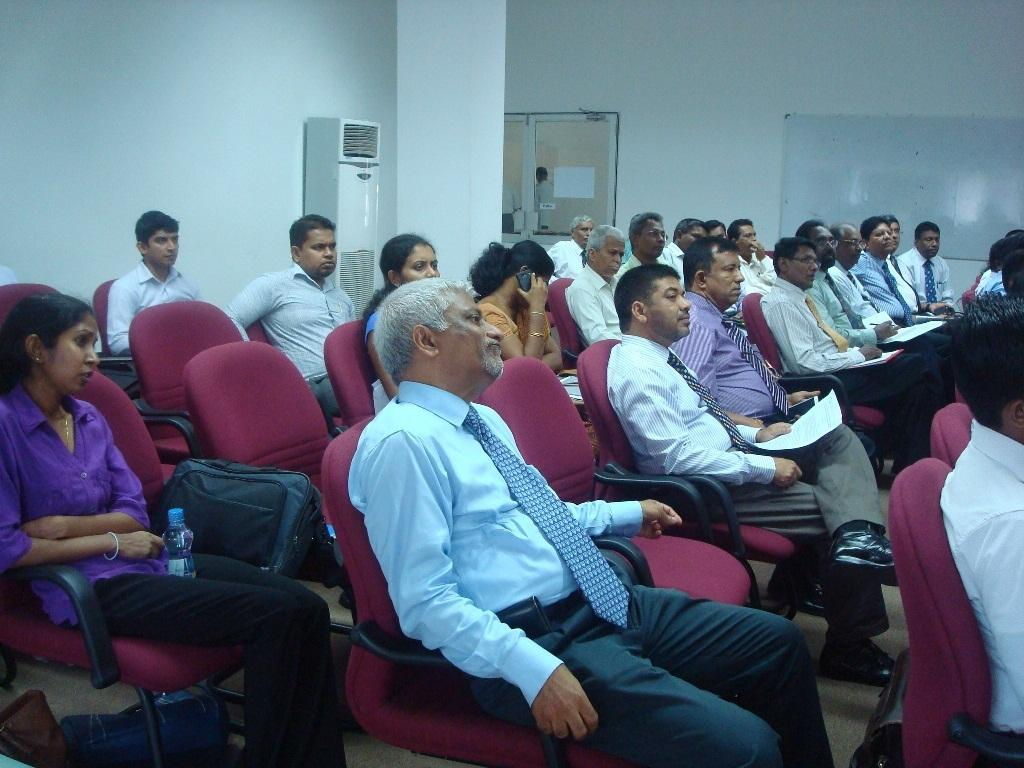What are the people in the image doing? The people in the image are sitting on chairs. What can be seen in the background of the image? There is an air conditioner and windows visible in the background of the image. What type of paste is being used by the fairies in the image? There are no fairies present in the image, so there is no paste being used. 